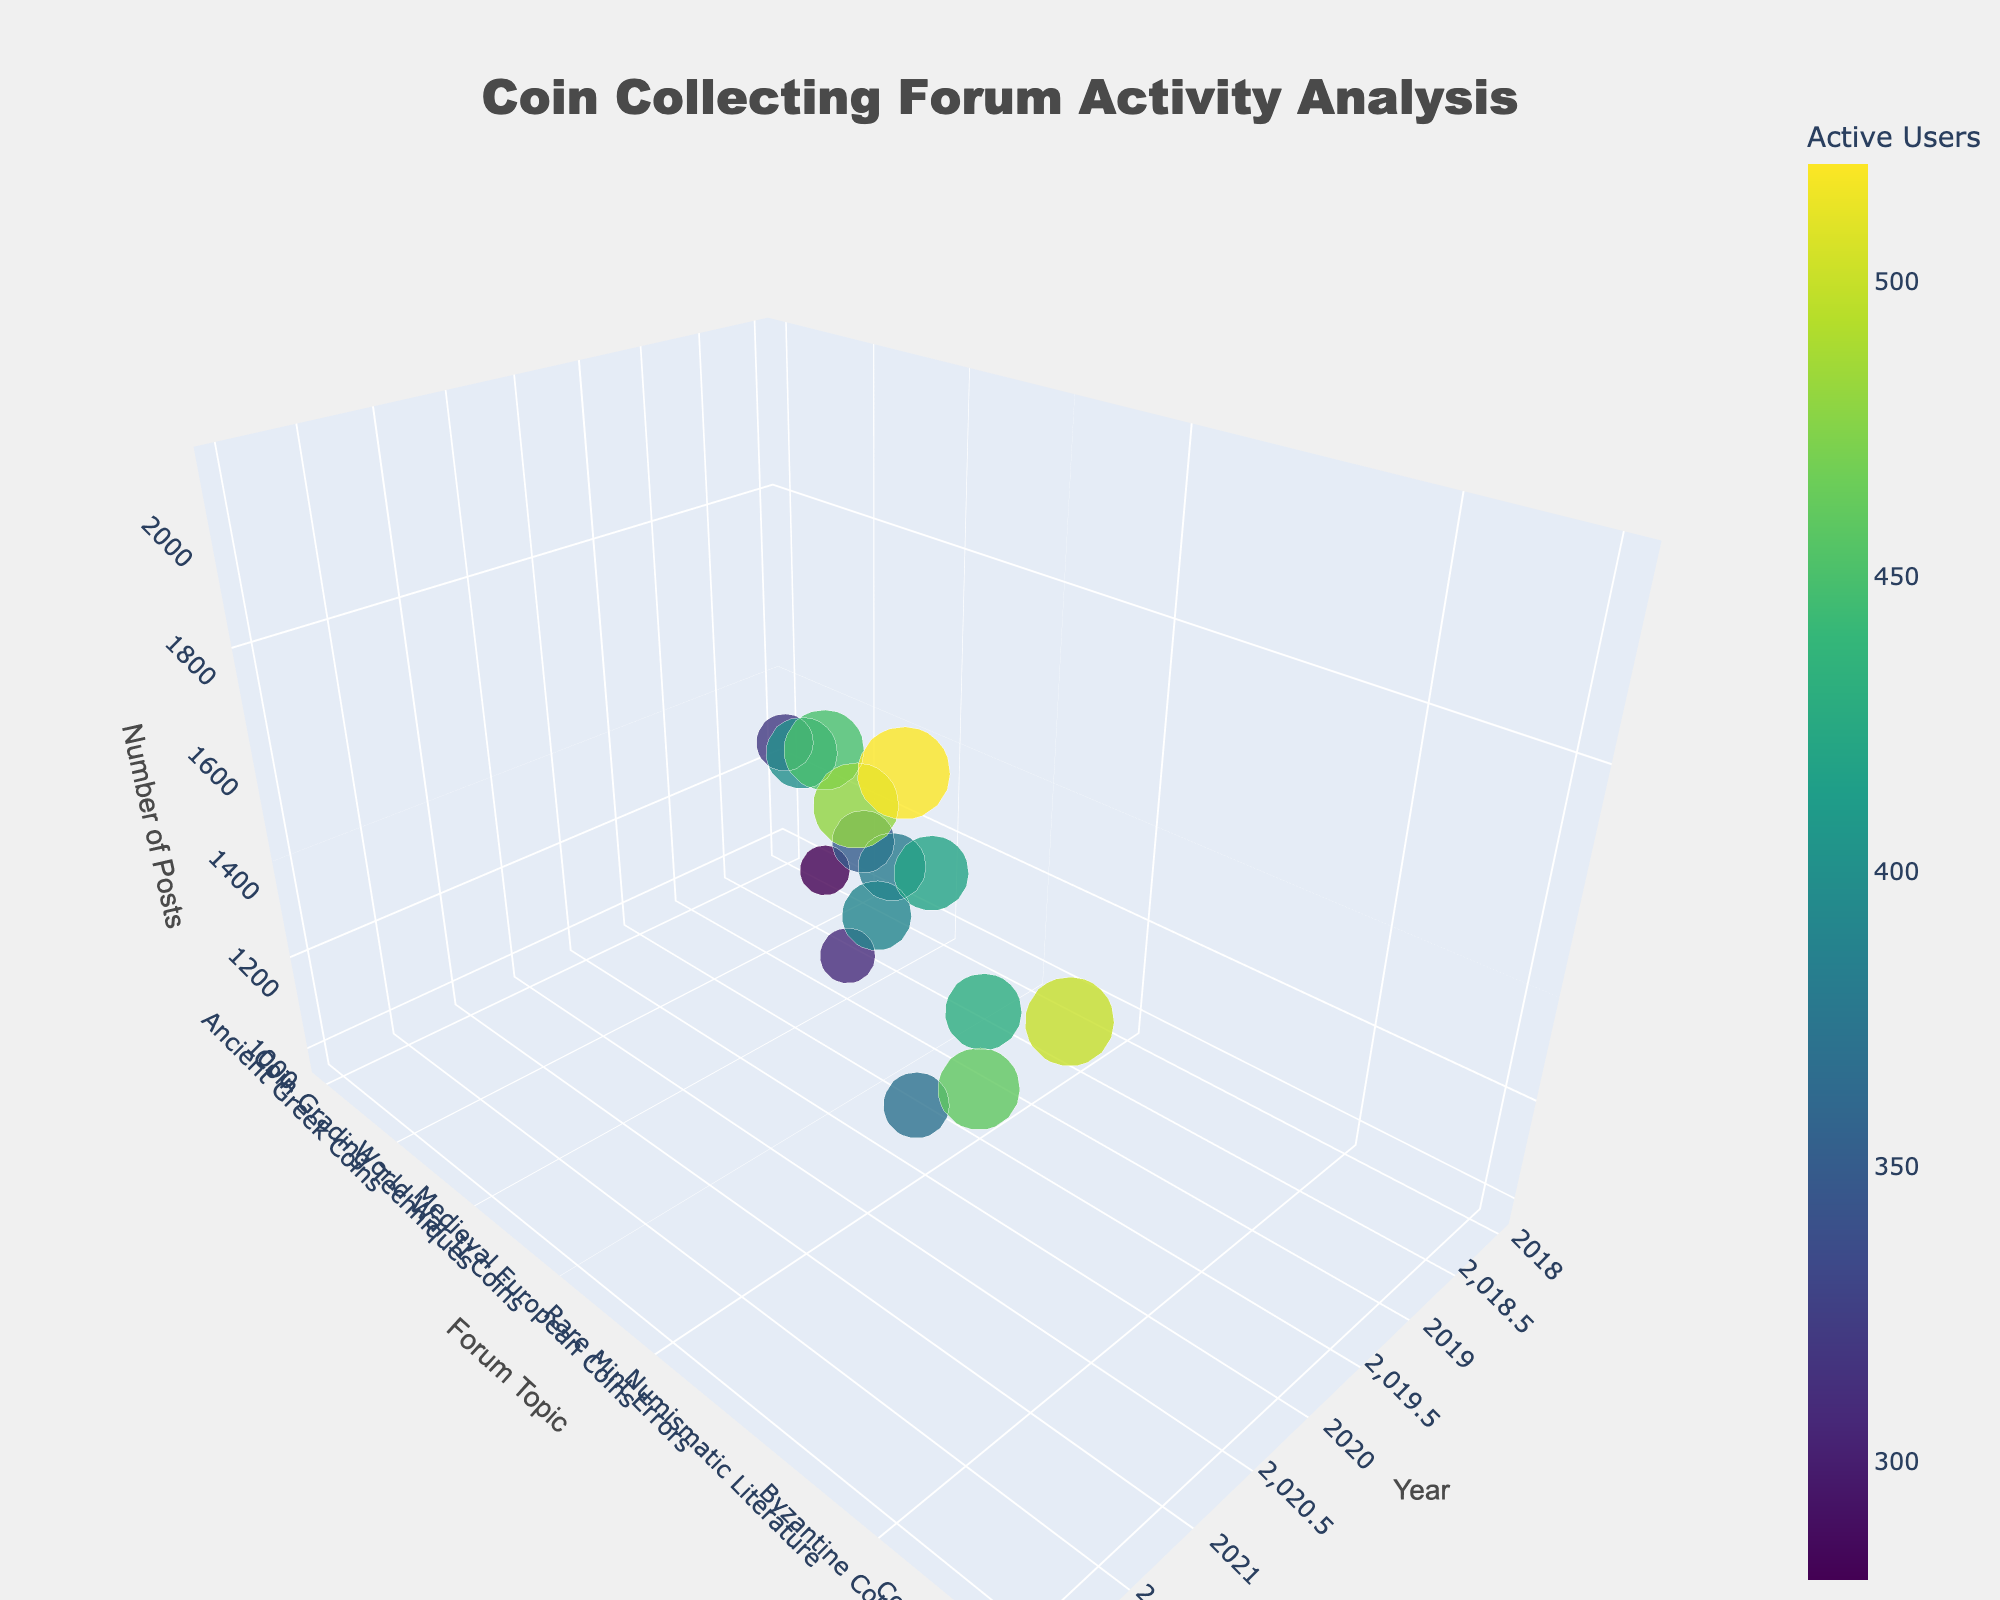What's the title of the 3D plot? The title is located at the top center of the figure. By observing the plot, the title reads "Coin Collecting Forum Activity Analysis."
Answer: Coin Collecting Forum Activity Analysis Which year had the topic "Chinese Cash Coins" posted about? By examining the y-axis for the forum topics and finding "Chinese Cash Coins," we then look at the corresponding x-axis value for the year.
Answer: 2021 How many posts were made on the topic "Byzantine Coinage" in 2022? Locate "Byzantine Coinage" on the y-axis, corresponding to the year 2022 on the x-axis. Follow these coordinates vertically to the z-axis to find the post count.
Answer: 2100 Which topic in 2020 had the least number of posts? First, filter the data points representing the year 2020. Then identify the data point with the lowest z-axis value among them. The topic associated with this data point has the least posts.
Answer: Coin Storage Solutions What is the average number of posts for "Coin Photography Tips" and "Coin Auction Strategies"? First, locate the data points for "Coin Photography Tips" and "Coin Auction Strategies" and find their post counts, 1300 and 1600 respectively. Average them: (1300 + 1600) / 2 = 1450.
Answer: 1450 Which topic had the highest number of active users in 2021? Look at the data points colored for the year 2021. The size and color intensity indicate the active users. Identify the topic with the largest size, highest color intensity.
Answer: Chinese Cash Coins Between 2018 and 2022, which year had the most diverse range of topics discussed? Compare the distribution of topics along the y-axis for each year. The year with the widest spread of unique topics vertically will have the most diverse range.
Answer: 2022 How does the number of posts on "Rare Mint Errors" in 2020 compare to "Modern Bullion Coins" in 2022? Locate both topics and observe their x-axis (year). Compare their z-axis values (number of posts). "Rare Mint Errors" has fewer posts when compared to "Modern Bullion Coins".
Answer: Less Which forum topic in 2019 had the highest number of posts? Filter for year 2019 and observe the height of the data points (z-axis). Identify the highest point among them.
Answer: Roman Imperial Coinage What is the total number of posts made in 2022 for the topics in the dataset? Find all the topics corresponding to the year 2022. Sum their post counts: 2100 + 1750 + 1900 = 5750.
Answer: 5750 